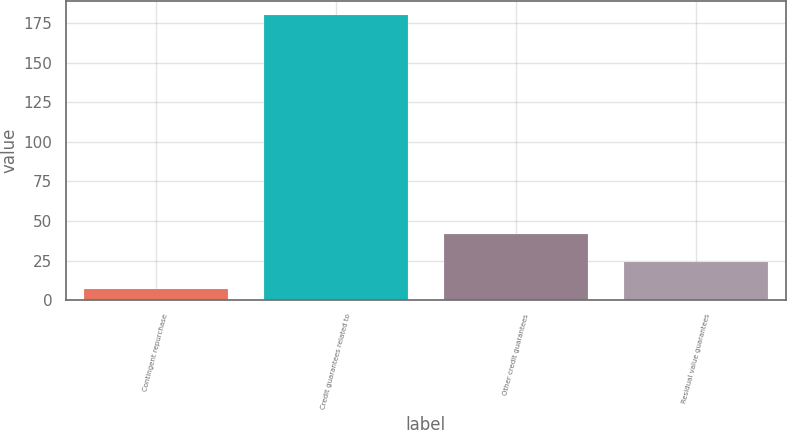Convert chart. <chart><loc_0><loc_0><loc_500><loc_500><bar_chart><fcel>Contingent repurchase<fcel>Credit guarantees related to<fcel>Other credit guarantees<fcel>Residual value guarantees<nl><fcel>7<fcel>180<fcel>41.6<fcel>24.3<nl></chart> 